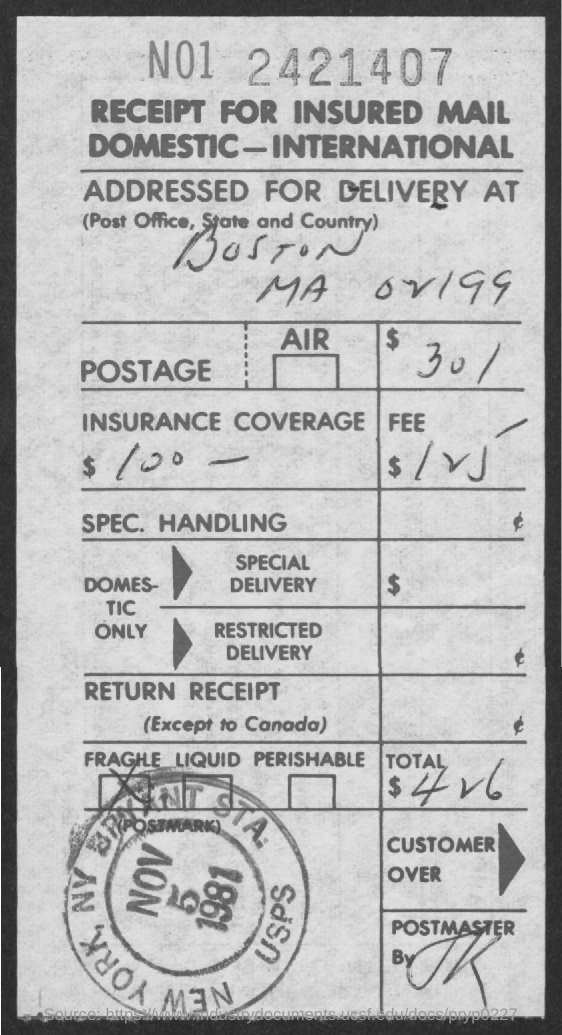What is the amount of postage?
Provide a succinct answer. $30. What is the insurance coverage specified?
Keep it short and to the point. $100. What is the date on the stamp?
Offer a very short reply. NOV 5 1981. 